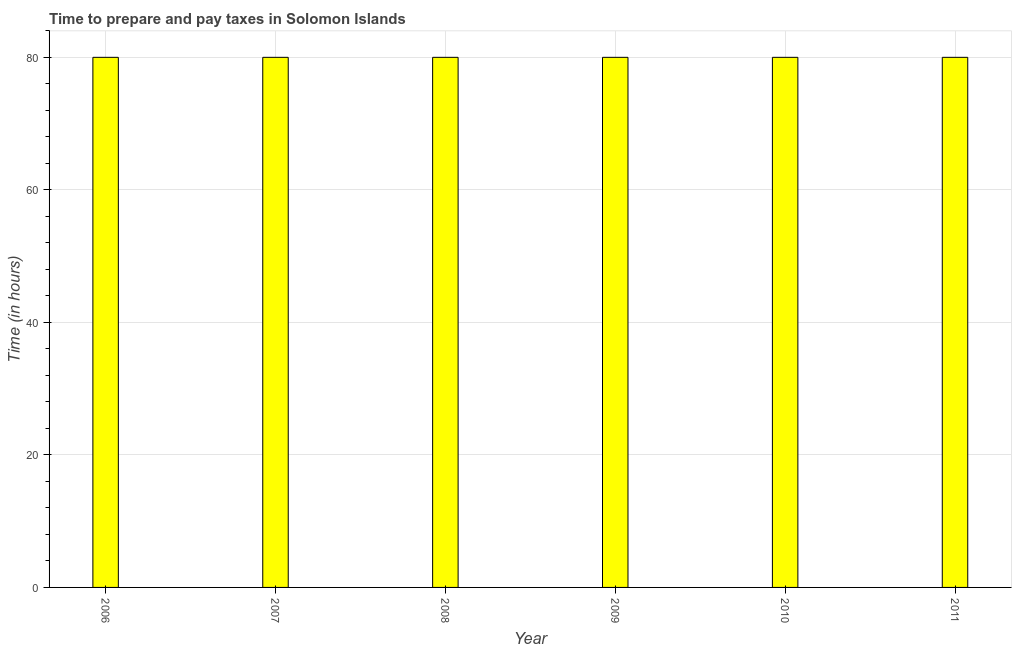Does the graph contain any zero values?
Ensure brevity in your answer.  No. Does the graph contain grids?
Provide a short and direct response. Yes. What is the title of the graph?
Provide a short and direct response. Time to prepare and pay taxes in Solomon Islands. What is the label or title of the Y-axis?
Your answer should be very brief. Time (in hours). What is the time to prepare and pay taxes in 2009?
Offer a very short reply. 80. Across all years, what is the maximum time to prepare and pay taxes?
Offer a terse response. 80. What is the sum of the time to prepare and pay taxes?
Make the answer very short. 480. What is the difference between the time to prepare and pay taxes in 2008 and 2011?
Offer a very short reply. 0. What is the average time to prepare and pay taxes per year?
Keep it short and to the point. 80. In how many years, is the time to prepare and pay taxes greater than 44 hours?
Make the answer very short. 6. Do a majority of the years between 2009 and 2006 (inclusive) have time to prepare and pay taxes greater than 28 hours?
Provide a short and direct response. Yes. Is the time to prepare and pay taxes in 2007 less than that in 2009?
Keep it short and to the point. No. Is the difference between the time to prepare and pay taxes in 2008 and 2011 greater than the difference between any two years?
Offer a very short reply. Yes. What is the difference between the highest and the second highest time to prepare and pay taxes?
Ensure brevity in your answer.  0. Is the sum of the time to prepare and pay taxes in 2008 and 2009 greater than the maximum time to prepare and pay taxes across all years?
Offer a very short reply. Yes. What is the difference between the highest and the lowest time to prepare and pay taxes?
Give a very brief answer. 0. In how many years, is the time to prepare and pay taxes greater than the average time to prepare and pay taxes taken over all years?
Ensure brevity in your answer.  0. How many bars are there?
Give a very brief answer. 6. Are all the bars in the graph horizontal?
Your answer should be compact. No. How many years are there in the graph?
Provide a short and direct response. 6. Are the values on the major ticks of Y-axis written in scientific E-notation?
Make the answer very short. No. What is the Time (in hours) of 2008?
Make the answer very short. 80. What is the Time (in hours) in 2009?
Ensure brevity in your answer.  80. What is the Time (in hours) of 2010?
Give a very brief answer. 80. What is the difference between the Time (in hours) in 2006 and 2007?
Ensure brevity in your answer.  0. What is the difference between the Time (in hours) in 2006 and 2008?
Provide a short and direct response. 0. What is the difference between the Time (in hours) in 2006 and 2010?
Your response must be concise. 0. What is the difference between the Time (in hours) in 2007 and 2008?
Offer a terse response. 0. What is the difference between the Time (in hours) in 2007 and 2009?
Offer a terse response. 0. What is the difference between the Time (in hours) in 2008 and 2011?
Your answer should be compact. 0. What is the difference between the Time (in hours) in 2009 and 2011?
Your answer should be very brief. 0. What is the ratio of the Time (in hours) in 2006 to that in 2007?
Offer a very short reply. 1. What is the ratio of the Time (in hours) in 2006 to that in 2009?
Ensure brevity in your answer.  1. What is the ratio of the Time (in hours) in 2006 to that in 2011?
Your response must be concise. 1. What is the ratio of the Time (in hours) in 2007 to that in 2008?
Ensure brevity in your answer.  1. What is the ratio of the Time (in hours) in 2007 to that in 2009?
Make the answer very short. 1. What is the ratio of the Time (in hours) in 2008 to that in 2009?
Provide a succinct answer. 1. What is the ratio of the Time (in hours) in 2008 to that in 2011?
Your answer should be very brief. 1. What is the ratio of the Time (in hours) in 2009 to that in 2010?
Ensure brevity in your answer.  1. 